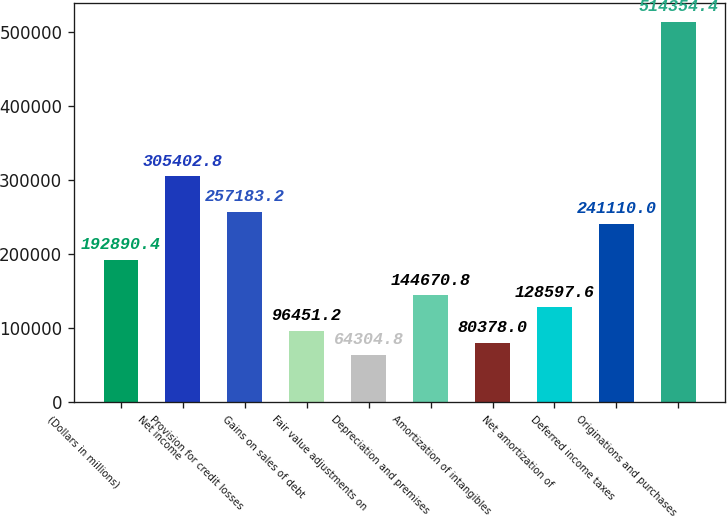<chart> <loc_0><loc_0><loc_500><loc_500><bar_chart><fcel>(Dollars in millions)<fcel>Net income<fcel>Provision for credit losses<fcel>Gains on sales of debt<fcel>Fair value adjustments on<fcel>Depreciation and premises<fcel>Amortization of intangibles<fcel>Net amortization of<fcel>Deferred income taxes<fcel>Originations and purchases<nl><fcel>192890<fcel>305403<fcel>257183<fcel>96451.2<fcel>64304.8<fcel>144671<fcel>80378<fcel>128598<fcel>241110<fcel>514354<nl></chart> 